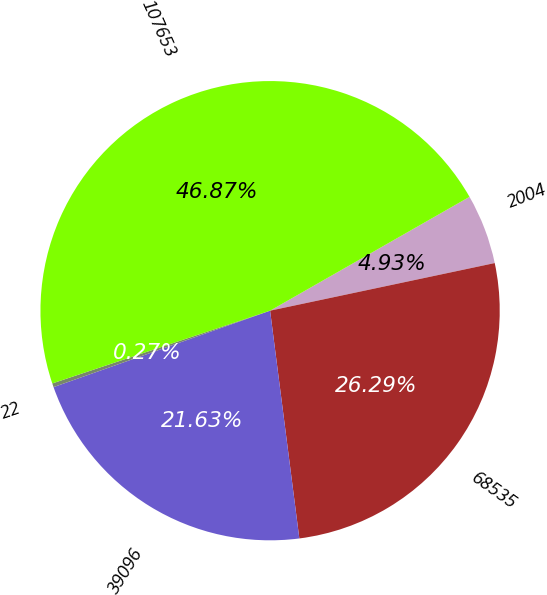Convert chart. <chart><loc_0><loc_0><loc_500><loc_500><pie_chart><fcel>2004<fcel>68535<fcel>39096<fcel>22<fcel>107653<nl><fcel>4.93%<fcel>26.29%<fcel>21.63%<fcel>0.27%<fcel>46.87%<nl></chart> 